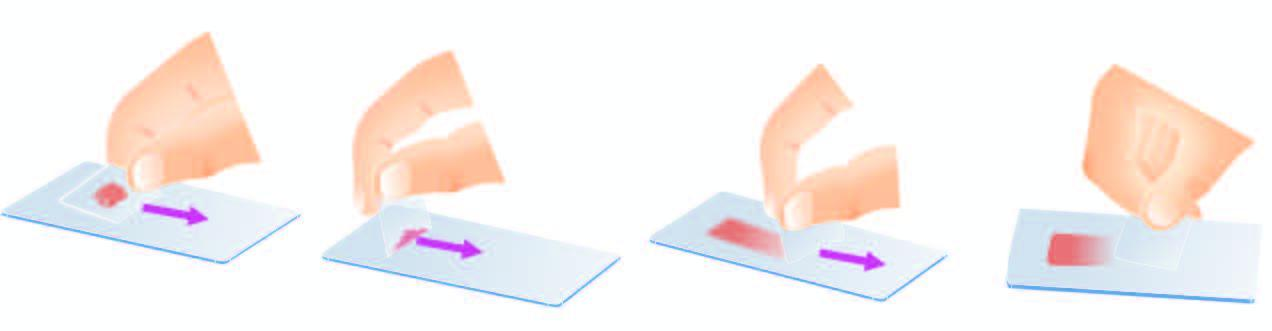re the new virions crush-smeared by flat pressure with cover slip or glass slide?
Answer the question using a single word or phrase. No 